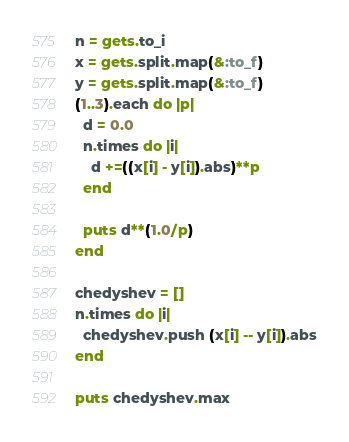Convert code to text. <code><loc_0><loc_0><loc_500><loc_500><_Ruby_>n = gets.to_i
x = gets.split.map(&:to_f)
y = gets.split.map(&:to_f)
(1..3).each do |p|
  d = 0.0
  n.times do |i|
    d +=((x[i] - y[i]).abs)**p
  end
  
  puts d**(1.0/p)
end

chedyshev = []
n.times do |i|
  chedyshev.push (x[i] -- y[i]).abs
end

puts chedyshev.max</code> 